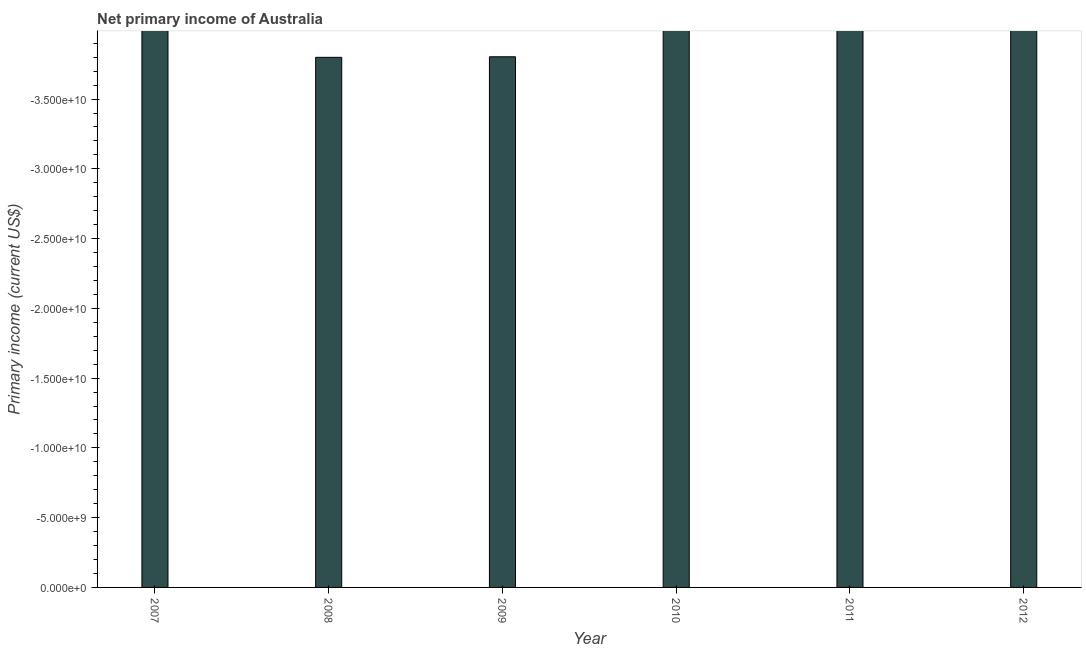What is the title of the graph?
Your answer should be compact. Net primary income of Australia. What is the label or title of the Y-axis?
Provide a succinct answer. Primary income (current US$). What is the amount of primary income in 2009?
Your response must be concise. 0. Across all years, what is the minimum amount of primary income?
Make the answer very short. 0. In how many years, is the amount of primary income greater than the average amount of primary income taken over all years?
Offer a terse response. 0. What is the difference between two consecutive major ticks on the Y-axis?
Offer a terse response. 5.00e+09. Are the values on the major ticks of Y-axis written in scientific E-notation?
Keep it short and to the point. Yes. What is the Primary income (current US$) in 2008?
Ensure brevity in your answer.  0. What is the Primary income (current US$) in 2010?
Your answer should be very brief. 0. What is the Primary income (current US$) of 2012?
Make the answer very short. 0. 